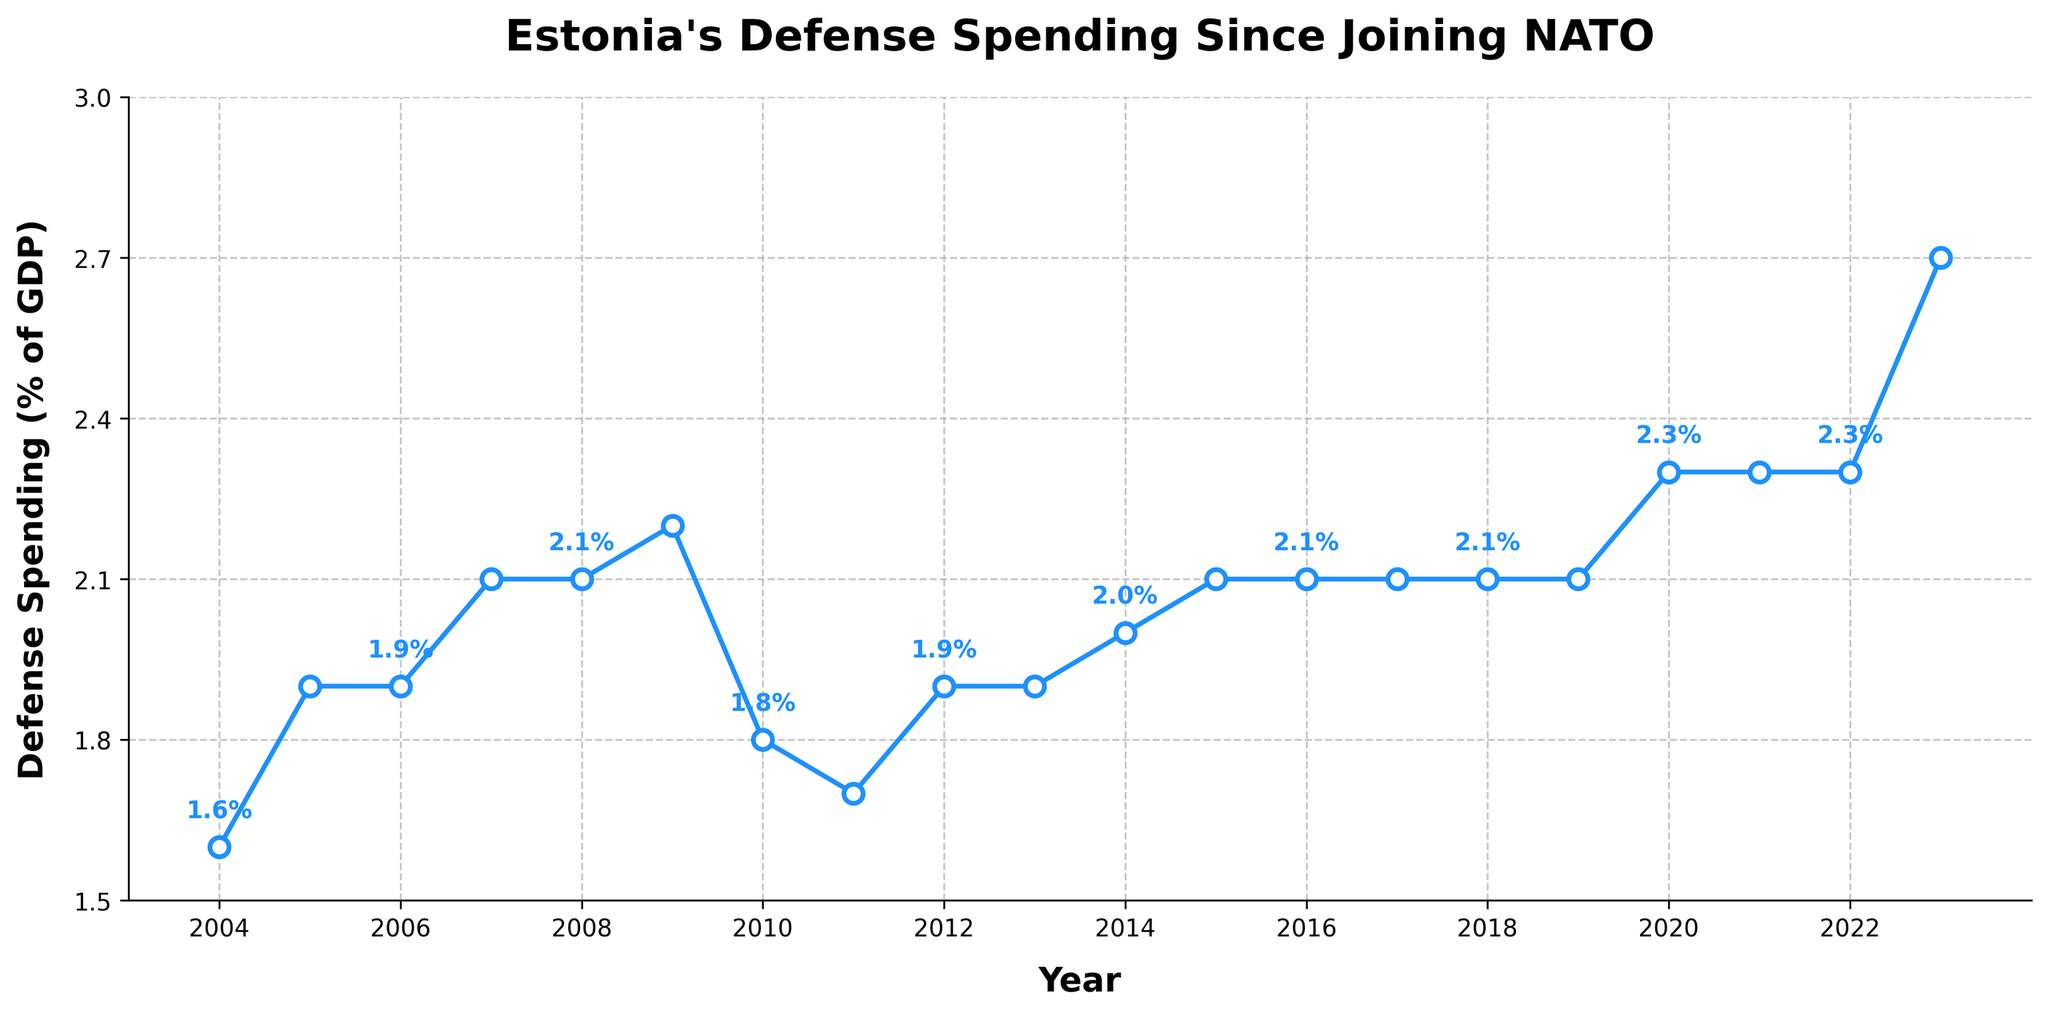What was the defense spending as a percentage of GDP in 2023? The figure shows the defense spending percentage for each year plotted as points on the line chart. Look at the value for 2023.
Answer: 2.7% How did the defense spending as a percentage of GDP change from 2010 to 2011? Compare the data points for 2010 and 2011. The percentage decreases from 1.8% in 2010 to 1.7% in 2011.
Answer: It decreased by 0.1% Which year had the highest defense spending as a percentage of GDP and what was the value? Look for the highest data point on the chart and note the corresponding year and value. The highest percentage is in 2023 with 2.7%.
Answer: 2023, 2.7% What is the overall trend of Estonia's defense spending as a percentage of GDP from 2004 to 2023? Observe the general direction in which all the points and the line trend. The overall trend is an increase, with fluctuations throughout the years.
Answer: Increasing trend What is the average defense spending as a percentage of GDP from 2004 to 2023? Add all the values from 2004 to 2023 and divide by the number of years (20). \((1.6 + 1.9 + 1.9 + 2.1 + 2.1 + 2.2 + 1.8 + 1.7 + 1.9 + 1.9 + 2.0 + 2.1 + 2.1 + 2.1 + 2.1 + 2.1 + 2.3 + 2.3 + 2.3 + 2.7) / 20 = 2.045\)
Answer: 2.05% During which years did Estonia's defense spending as a percentage of GDP remain constant? Look for the flat sections of the line chart where the percentages do not change over consecutive years. Defense spending remained constant at 2.1% from 2006 to 2008, 2015 to 2019, and 2011 and 2012.
Answer: 2006-2008, 2015-2018, 2011-2012 How does the defense spending in 2020 compare to that in 2004? Compare the data points for both years. In 2020, the spending was 2.3%, which is higher than the 1.6% in 2004.
Answer: 2020 was higher by 0.7% What is the difference in defense spending percentage between the highest and lowest years? Identify the highest and lowest percentages from the chart and subtract the smallest value from the highest. \(\text{Highest: } 2.7\%, \text{Lowest: } 1.6\%). \text{Difference} = 2.7\% - 1.6\% = 1.1\%\)
Answer: 1.1% In which year did Estonia first reach a defense spending of 2.0% or more? Find the first year that has a data point equal to or greater than 2.0%. This is the year 2007.
Answer: 2007 